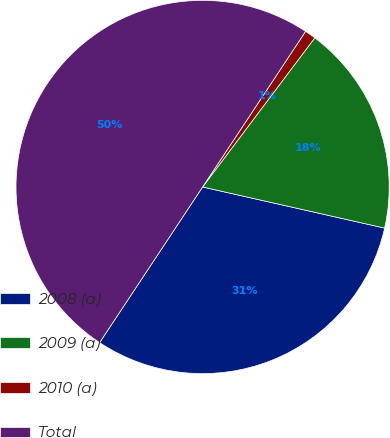Convert chart to OTSL. <chart><loc_0><loc_0><loc_500><loc_500><pie_chart><fcel>2008 (a)<fcel>2009 (a)<fcel>2010 (a)<fcel>Total<nl><fcel>30.77%<fcel>18.27%<fcel>0.96%<fcel>50.0%<nl></chart> 